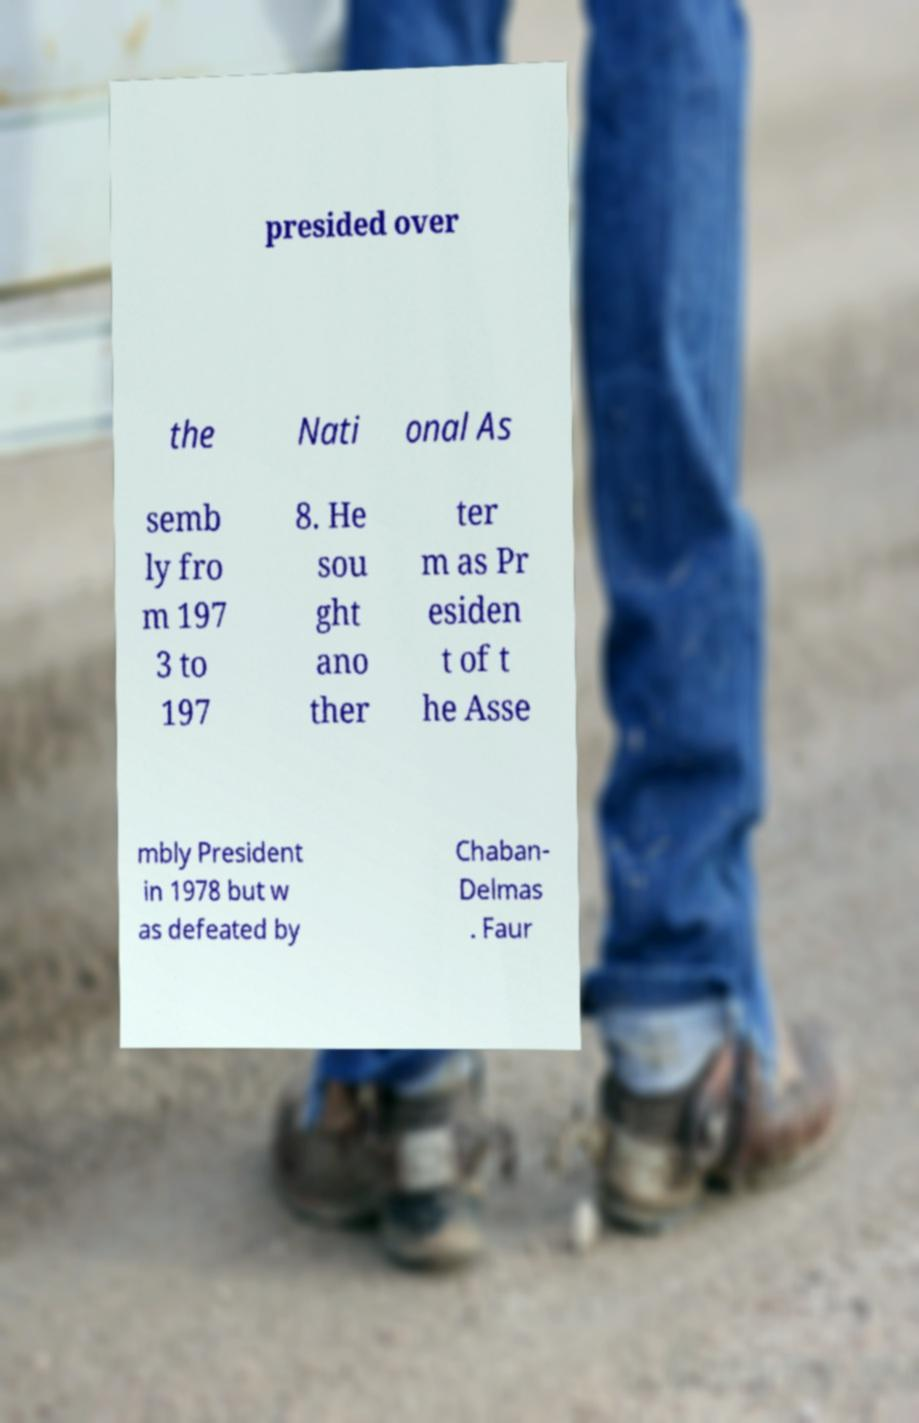What messages or text are displayed in this image? I need them in a readable, typed format. presided over the Nati onal As semb ly fro m 197 3 to 197 8. He sou ght ano ther ter m as Pr esiden t of t he Asse mbly President in 1978 but w as defeated by Chaban- Delmas . Faur 